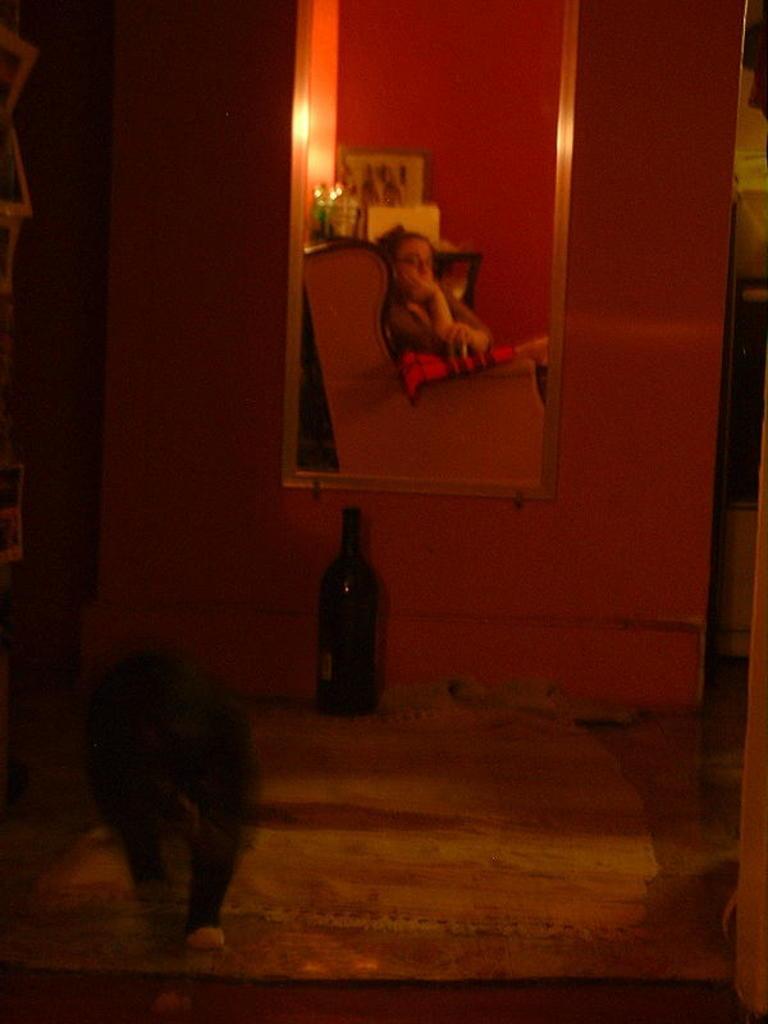How would you summarize this image in a sentence or two? In this image, we can see a mirror on the wall. We can see few reflections in the mirror. Here a woman is sitting on the chair. Background we can see so many objects and wall. In the middle of the image, we can see a bottle, few clothes. Left side of the image, there is an animal. 